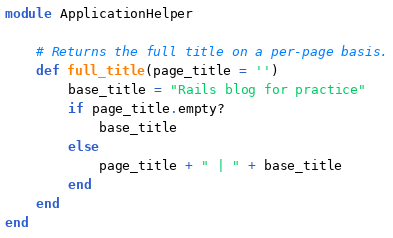<code> <loc_0><loc_0><loc_500><loc_500><_Ruby_>module ApplicationHelper

    # Returns the full title on a per-page basis.
    def full_title(page_title = '')
        base_title = "Rails blog for practice"
        if page_title.empty?
            base_title
        else 
            page_title + " | " + base_title
        end
    end
end
</code> 